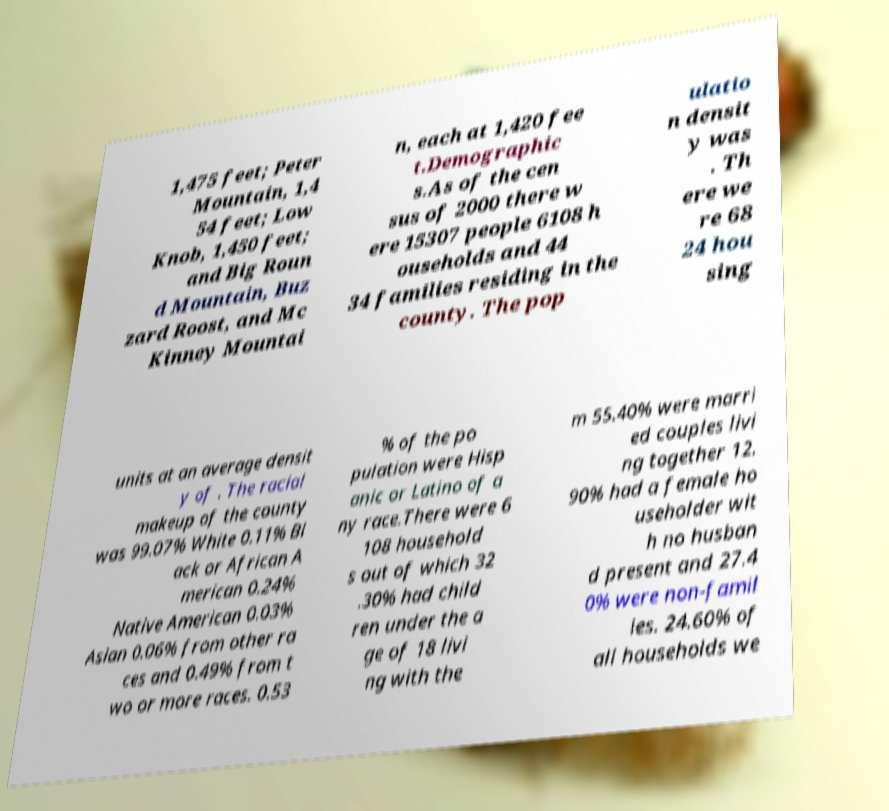I need the written content from this picture converted into text. Can you do that? 1,475 feet; Peter Mountain, 1,4 54 feet; Low Knob, 1,450 feet; and Big Roun d Mountain, Buz zard Roost, and Mc Kinney Mountai n, each at 1,420 fee t.Demographic s.As of the cen sus of 2000 there w ere 15307 people 6108 h ouseholds and 44 34 families residing in the county. The pop ulatio n densit y was . Th ere we re 68 24 hou sing units at an average densit y of . The racial makeup of the county was 99.07% White 0.11% Bl ack or African A merican 0.24% Native American 0.03% Asian 0.06% from other ra ces and 0.49% from t wo or more races. 0.53 % of the po pulation were Hisp anic or Latino of a ny race.There were 6 108 household s out of which 32 .30% had child ren under the a ge of 18 livi ng with the m 55.40% were marri ed couples livi ng together 12. 90% had a female ho useholder wit h no husban d present and 27.4 0% were non-famil ies. 24.60% of all households we 